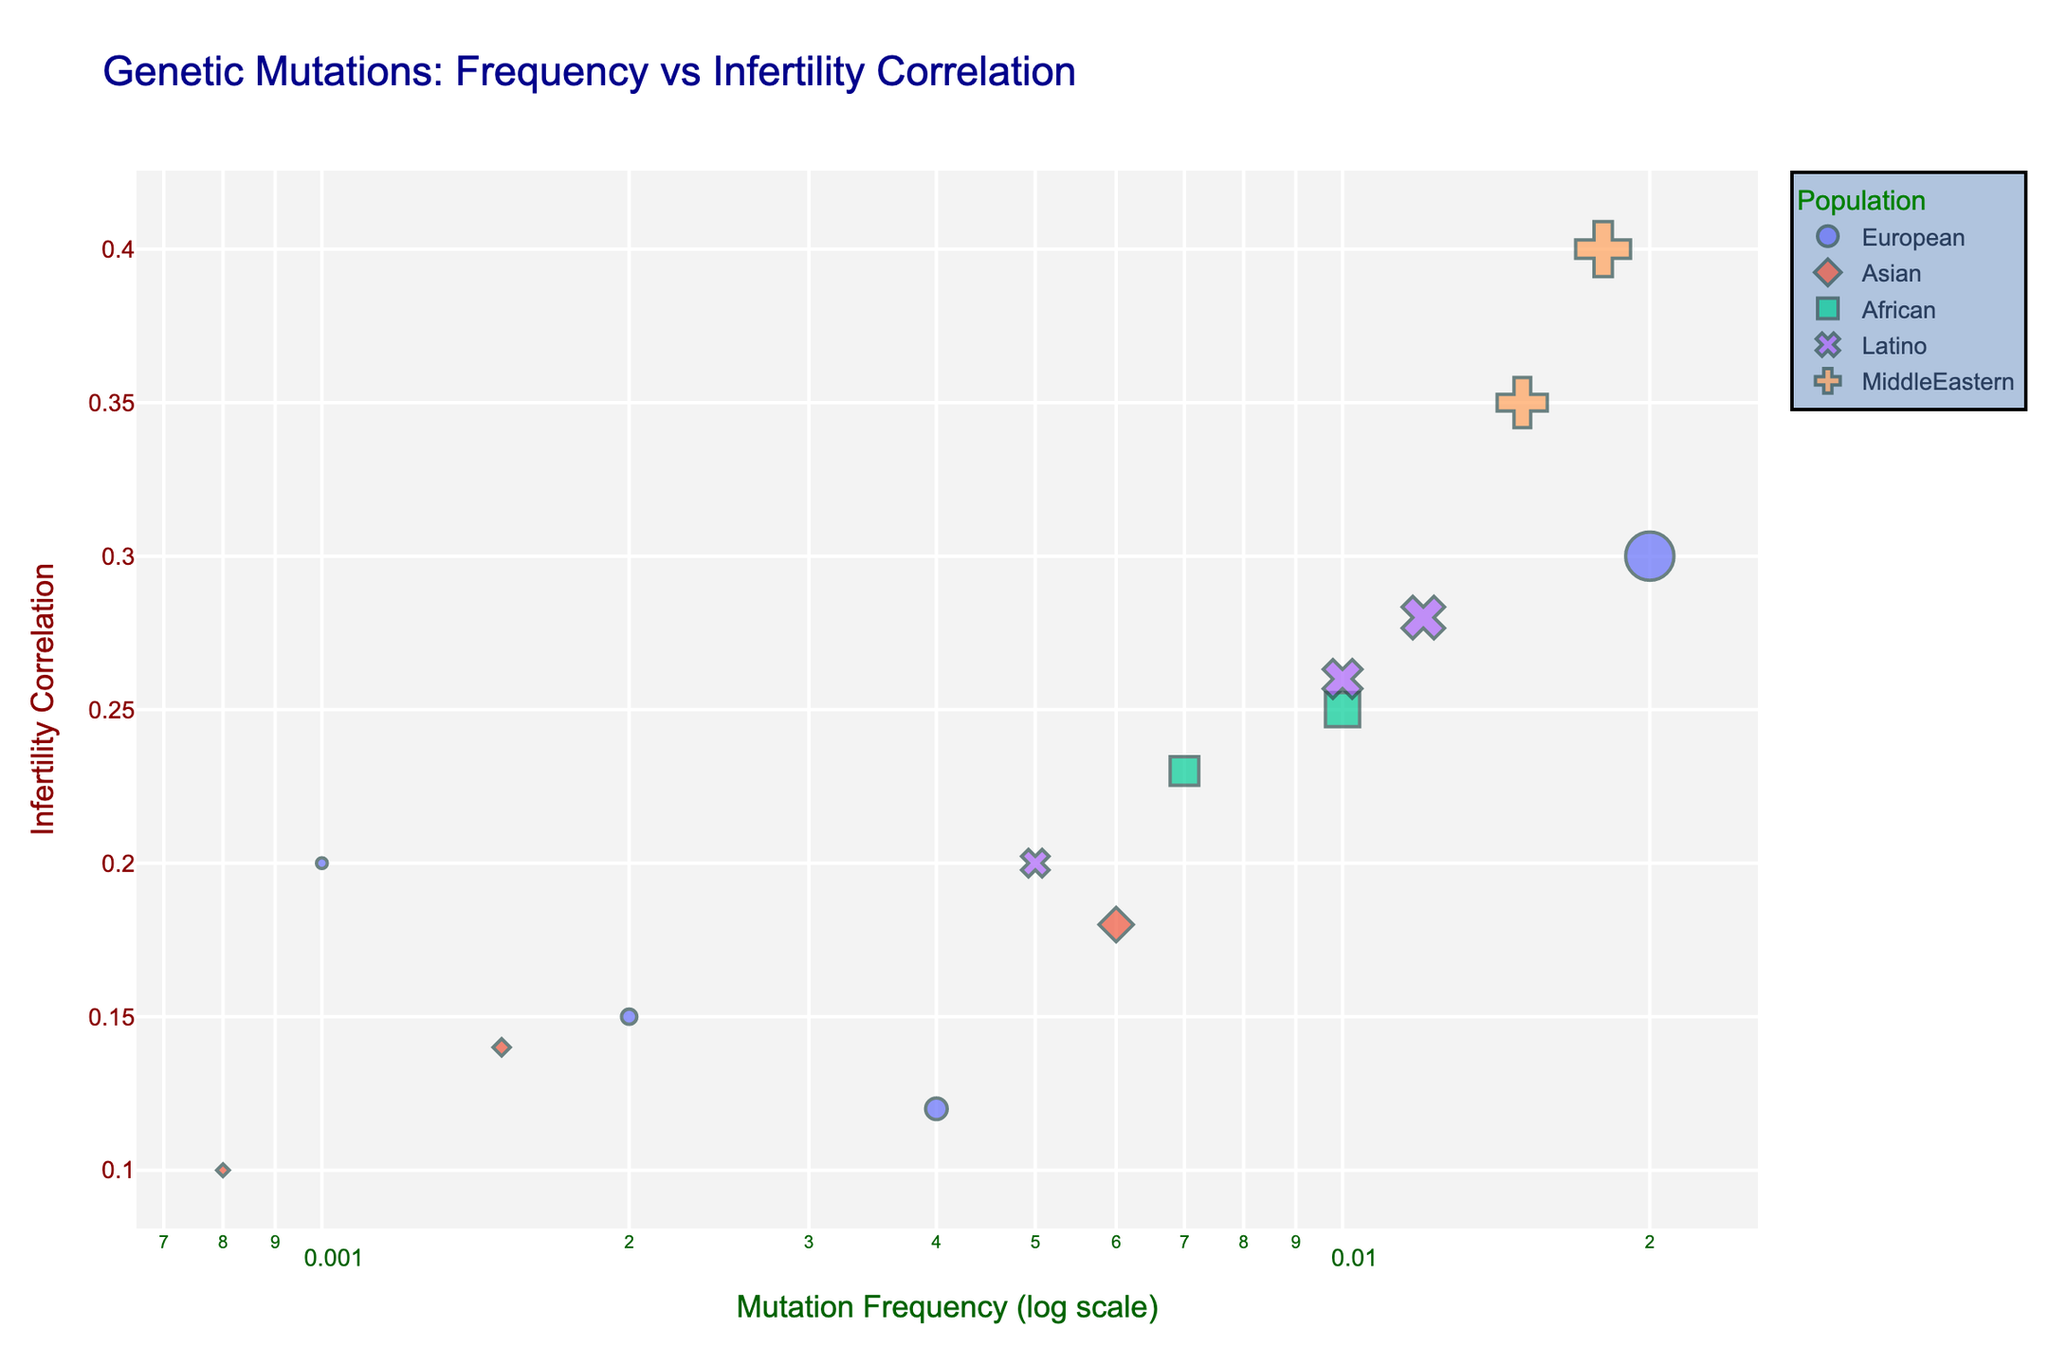What is the title of the figure? The title is often placed at the top of the figure and provides a description of what the figure is about. In this case, it describes the relationship between genetic mutation frequencies and infertility correlation across different populations.
Answer: Genetic Mutations: Frequency vs Infertility Correlation Which genetic mutation has the highest frequency? To find the highest frequency, look for the largest symbol on the x-axis. In this case, the mutation with the log scale x value corresponding to the highest frequency is MTHFR.
Answer: MTHFR Which population has the genetic mutation with the highest infertility correlation? The genetic mutation with the highest infertility correlation can be found by locating the point highest on the y-axis. In this case, it is KLHL12, which belongs to the Middle Eastern population.
Answer: Middle Eastern How many data points are there in total? Count the number of distinct points on the scatter plot, each representing a unique genetic mutation in a population.
Answer: 14 Which two genetic mutations in the European population have the closest infertility correlation values? Identify the points corresponding to the European population and compare their y-axis values. The mutations PRDM1 and BRCA1 have the closest infertility correlation values of 0.12 and 0.15, respectively.
Answer: PRDM1 and BRCA1 What is the median infertility correlation value for genetic mutations in the African population? There are two genetic mutations (CFTR and AMH2) in the African population. The median is the average of the two values, (0.25 + 0.23) / 2.
Answer: 0.24 Which population has the widest range of infertility correlation values? Determine the range by subtracting the lowest infertility correlation value from the highest within each population. The Middle Eastern population, with a range from KLHL12 (0.4) to PCOS1 (0.35), has the widest range.
Answer: Middle Eastern Among the listed genetic mutations, which one has the smallest frequency in the Asian population? Compare the x-values for genetic mutations in the Asian population. NR5A1 has the smallest frequency of 0.0008.
Answer: NR5A1 Which genetic mutation has a higher infertility correlation, FSHR or BRCA1? Compare the y-axis values for FSHR and BRCA1. FSHR has a correlation of 0.28, while BRCA1 has 0.15.
Answer: FSHR What is the sum of the frequencies of all genetic mutations in the Latino population? Add the x-axis frequencies for TAF4B (0.01), FSHR (0.012), and FMR1 (0.005) in the Latino population. 0.01 + 0.012 + 0.005 = 0.027
Answer: 0.027 